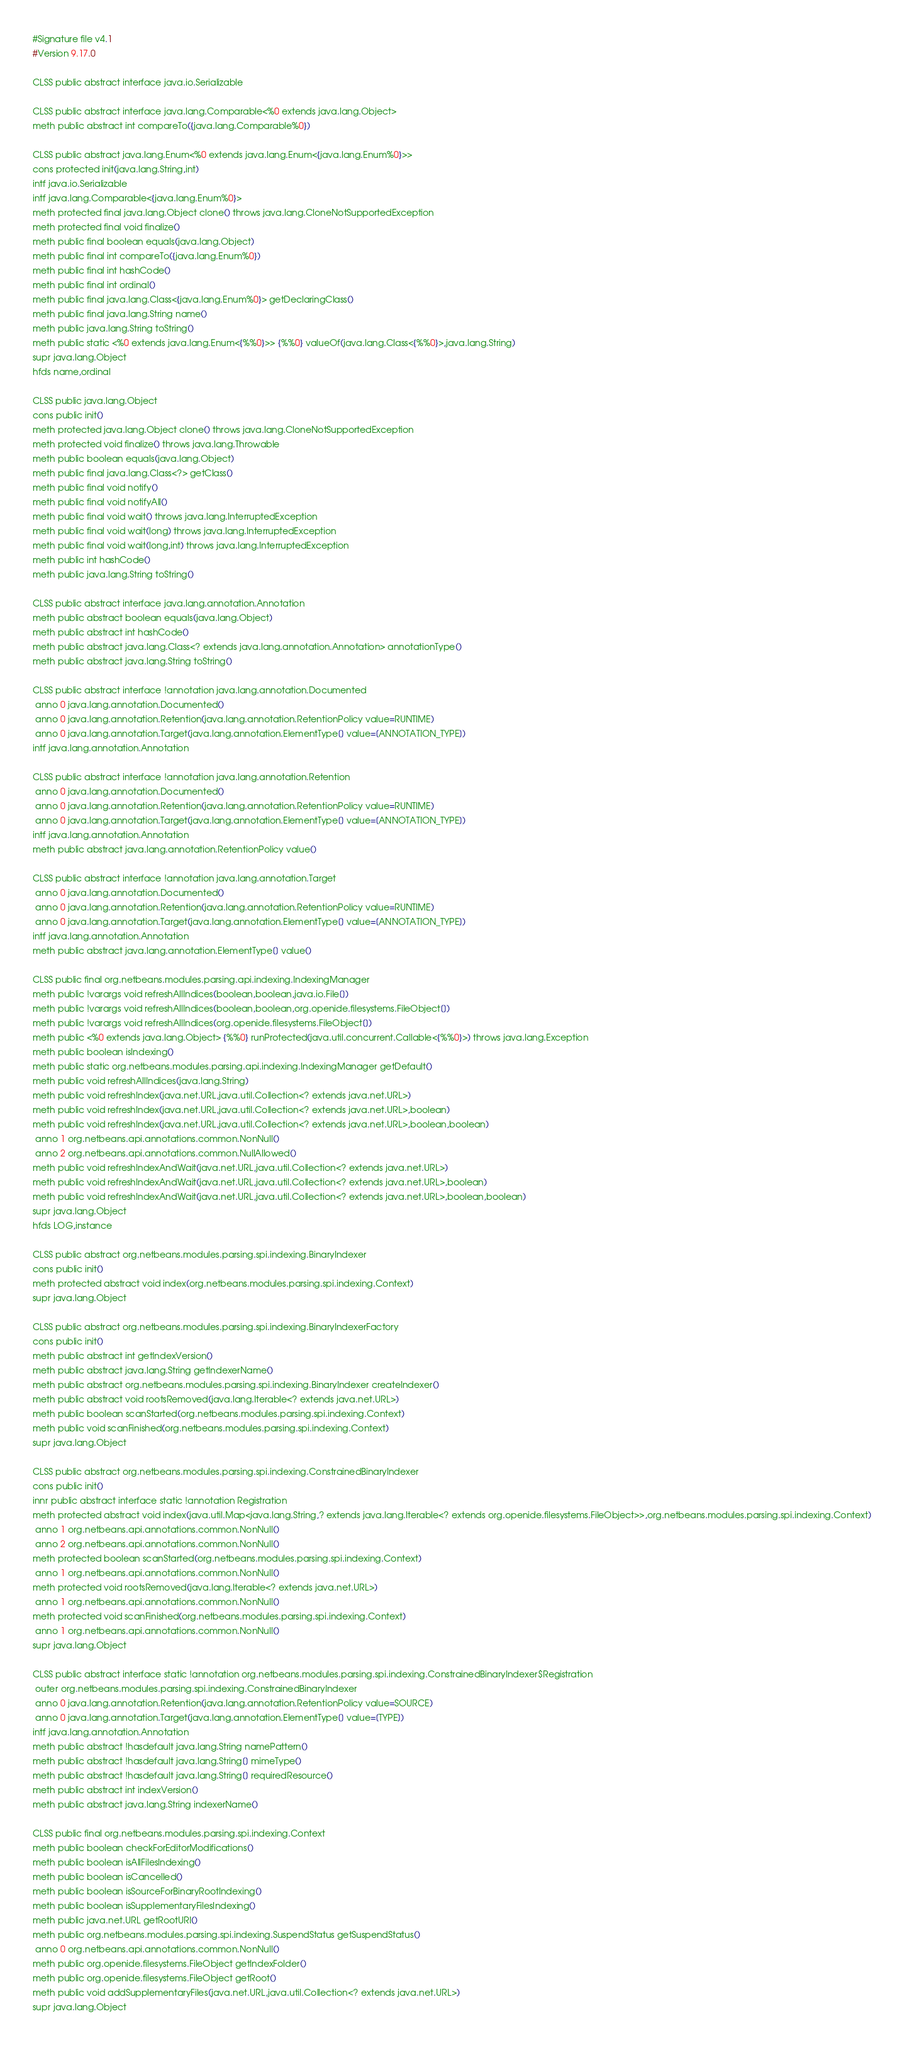Convert code to text. <code><loc_0><loc_0><loc_500><loc_500><_SML_>#Signature file v4.1
#Version 9.17.0

CLSS public abstract interface java.io.Serializable

CLSS public abstract interface java.lang.Comparable<%0 extends java.lang.Object>
meth public abstract int compareTo({java.lang.Comparable%0})

CLSS public abstract java.lang.Enum<%0 extends java.lang.Enum<{java.lang.Enum%0}>>
cons protected init(java.lang.String,int)
intf java.io.Serializable
intf java.lang.Comparable<{java.lang.Enum%0}>
meth protected final java.lang.Object clone() throws java.lang.CloneNotSupportedException
meth protected final void finalize()
meth public final boolean equals(java.lang.Object)
meth public final int compareTo({java.lang.Enum%0})
meth public final int hashCode()
meth public final int ordinal()
meth public final java.lang.Class<{java.lang.Enum%0}> getDeclaringClass()
meth public final java.lang.String name()
meth public java.lang.String toString()
meth public static <%0 extends java.lang.Enum<{%%0}>> {%%0} valueOf(java.lang.Class<{%%0}>,java.lang.String)
supr java.lang.Object
hfds name,ordinal

CLSS public java.lang.Object
cons public init()
meth protected java.lang.Object clone() throws java.lang.CloneNotSupportedException
meth protected void finalize() throws java.lang.Throwable
meth public boolean equals(java.lang.Object)
meth public final java.lang.Class<?> getClass()
meth public final void notify()
meth public final void notifyAll()
meth public final void wait() throws java.lang.InterruptedException
meth public final void wait(long) throws java.lang.InterruptedException
meth public final void wait(long,int) throws java.lang.InterruptedException
meth public int hashCode()
meth public java.lang.String toString()

CLSS public abstract interface java.lang.annotation.Annotation
meth public abstract boolean equals(java.lang.Object)
meth public abstract int hashCode()
meth public abstract java.lang.Class<? extends java.lang.annotation.Annotation> annotationType()
meth public abstract java.lang.String toString()

CLSS public abstract interface !annotation java.lang.annotation.Documented
 anno 0 java.lang.annotation.Documented()
 anno 0 java.lang.annotation.Retention(java.lang.annotation.RetentionPolicy value=RUNTIME)
 anno 0 java.lang.annotation.Target(java.lang.annotation.ElementType[] value=[ANNOTATION_TYPE])
intf java.lang.annotation.Annotation

CLSS public abstract interface !annotation java.lang.annotation.Retention
 anno 0 java.lang.annotation.Documented()
 anno 0 java.lang.annotation.Retention(java.lang.annotation.RetentionPolicy value=RUNTIME)
 anno 0 java.lang.annotation.Target(java.lang.annotation.ElementType[] value=[ANNOTATION_TYPE])
intf java.lang.annotation.Annotation
meth public abstract java.lang.annotation.RetentionPolicy value()

CLSS public abstract interface !annotation java.lang.annotation.Target
 anno 0 java.lang.annotation.Documented()
 anno 0 java.lang.annotation.Retention(java.lang.annotation.RetentionPolicy value=RUNTIME)
 anno 0 java.lang.annotation.Target(java.lang.annotation.ElementType[] value=[ANNOTATION_TYPE])
intf java.lang.annotation.Annotation
meth public abstract java.lang.annotation.ElementType[] value()

CLSS public final org.netbeans.modules.parsing.api.indexing.IndexingManager
meth public !varargs void refreshAllIndices(boolean,boolean,java.io.File[])
meth public !varargs void refreshAllIndices(boolean,boolean,org.openide.filesystems.FileObject[])
meth public !varargs void refreshAllIndices(org.openide.filesystems.FileObject[])
meth public <%0 extends java.lang.Object> {%%0} runProtected(java.util.concurrent.Callable<{%%0}>) throws java.lang.Exception
meth public boolean isIndexing()
meth public static org.netbeans.modules.parsing.api.indexing.IndexingManager getDefault()
meth public void refreshAllIndices(java.lang.String)
meth public void refreshIndex(java.net.URL,java.util.Collection<? extends java.net.URL>)
meth public void refreshIndex(java.net.URL,java.util.Collection<? extends java.net.URL>,boolean)
meth public void refreshIndex(java.net.URL,java.util.Collection<? extends java.net.URL>,boolean,boolean)
 anno 1 org.netbeans.api.annotations.common.NonNull()
 anno 2 org.netbeans.api.annotations.common.NullAllowed()
meth public void refreshIndexAndWait(java.net.URL,java.util.Collection<? extends java.net.URL>)
meth public void refreshIndexAndWait(java.net.URL,java.util.Collection<? extends java.net.URL>,boolean)
meth public void refreshIndexAndWait(java.net.URL,java.util.Collection<? extends java.net.URL>,boolean,boolean)
supr java.lang.Object
hfds LOG,instance

CLSS public abstract org.netbeans.modules.parsing.spi.indexing.BinaryIndexer
cons public init()
meth protected abstract void index(org.netbeans.modules.parsing.spi.indexing.Context)
supr java.lang.Object

CLSS public abstract org.netbeans.modules.parsing.spi.indexing.BinaryIndexerFactory
cons public init()
meth public abstract int getIndexVersion()
meth public abstract java.lang.String getIndexerName()
meth public abstract org.netbeans.modules.parsing.spi.indexing.BinaryIndexer createIndexer()
meth public abstract void rootsRemoved(java.lang.Iterable<? extends java.net.URL>)
meth public boolean scanStarted(org.netbeans.modules.parsing.spi.indexing.Context)
meth public void scanFinished(org.netbeans.modules.parsing.spi.indexing.Context)
supr java.lang.Object

CLSS public abstract org.netbeans.modules.parsing.spi.indexing.ConstrainedBinaryIndexer
cons public init()
innr public abstract interface static !annotation Registration
meth protected abstract void index(java.util.Map<java.lang.String,? extends java.lang.Iterable<? extends org.openide.filesystems.FileObject>>,org.netbeans.modules.parsing.spi.indexing.Context)
 anno 1 org.netbeans.api.annotations.common.NonNull()
 anno 2 org.netbeans.api.annotations.common.NonNull()
meth protected boolean scanStarted(org.netbeans.modules.parsing.spi.indexing.Context)
 anno 1 org.netbeans.api.annotations.common.NonNull()
meth protected void rootsRemoved(java.lang.Iterable<? extends java.net.URL>)
 anno 1 org.netbeans.api.annotations.common.NonNull()
meth protected void scanFinished(org.netbeans.modules.parsing.spi.indexing.Context)
 anno 1 org.netbeans.api.annotations.common.NonNull()
supr java.lang.Object

CLSS public abstract interface static !annotation org.netbeans.modules.parsing.spi.indexing.ConstrainedBinaryIndexer$Registration
 outer org.netbeans.modules.parsing.spi.indexing.ConstrainedBinaryIndexer
 anno 0 java.lang.annotation.Retention(java.lang.annotation.RetentionPolicy value=SOURCE)
 anno 0 java.lang.annotation.Target(java.lang.annotation.ElementType[] value=[TYPE])
intf java.lang.annotation.Annotation
meth public abstract !hasdefault java.lang.String namePattern()
meth public abstract !hasdefault java.lang.String[] mimeType()
meth public abstract !hasdefault java.lang.String[] requiredResource()
meth public abstract int indexVersion()
meth public abstract java.lang.String indexerName()

CLSS public final org.netbeans.modules.parsing.spi.indexing.Context
meth public boolean checkForEditorModifications()
meth public boolean isAllFilesIndexing()
meth public boolean isCancelled()
meth public boolean isSourceForBinaryRootIndexing()
meth public boolean isSupplementaryFilesIndexing()
meth public java.net.URL getRootURI()
meth public org.netbeans.modules.parsing.spi.indexing.SuspendStatus getSuspendStatus()
 anno 0 org.netbeans.api.annotations.common.NonNull()
meth public org.openide.filesystems.FileObject getIndexFolder()
meth public org.openide.filesystems.FileObject getRoot()
meth public void addSupplementaryFiles(java.net.URL,java.util.Collection<? extends java.net.URL>)
supr java.lang.Object</code> 